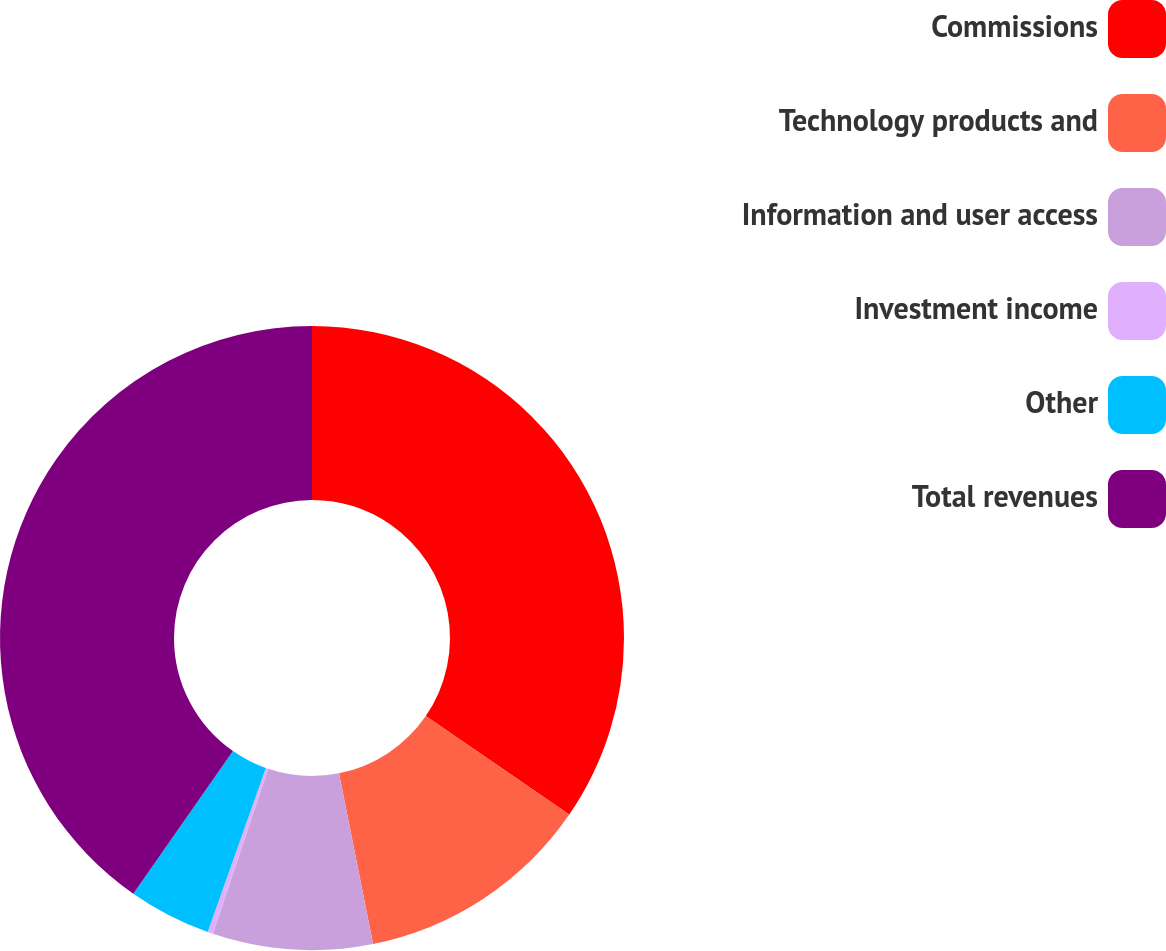Convert chart. <chart><loc_0><loc_0><loc_500><loc_500><pie_chart><fcel>Commissions<fcel>Technology products and<fcel>Information and user access<fcel>Investment income<fcel>Other<fcel>Total revenues<nl><fcel>34.57%<fcel>12.29%<fcel>8.28%<fcel>0.28%<fcel>4.28%<fcel>40.29%<nl></chart> 